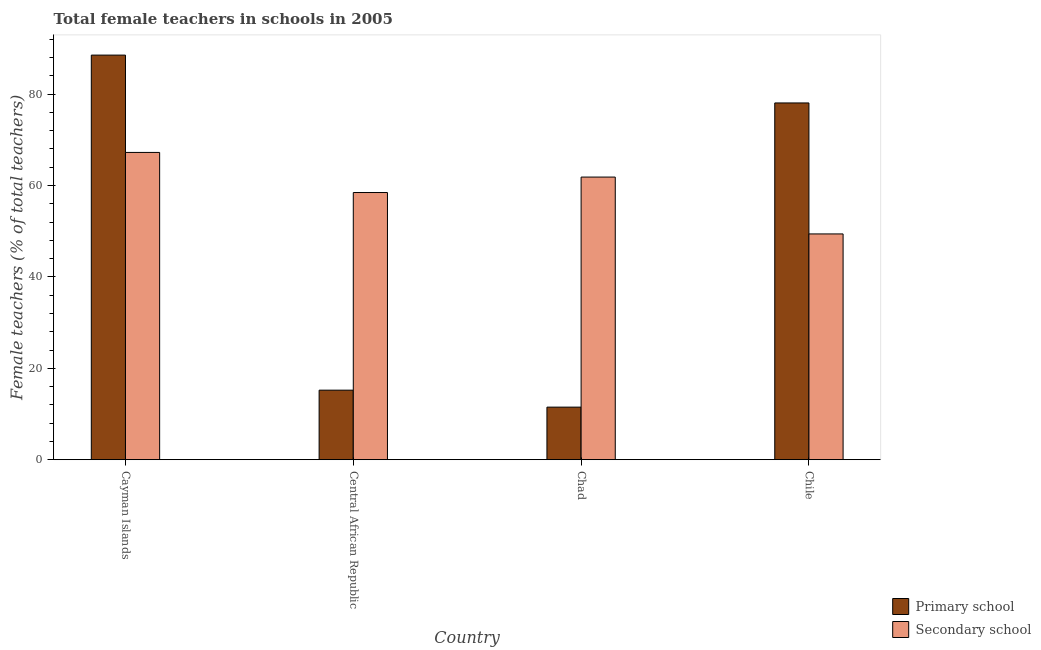How many bars are there on the 2nd tick from the left?
Your answer should be very brief. 2. What is the label of the 3rd group of bars from the left?
Offer a terse response. Chad. What is the percentage of female teachers in primary schools in Chad?
Your answer should be compact. 11.5. Across all countries, what is the maximum percentage of female teachers in secondary schools?
Offer a terse response. 67.24. Across all countries, what is the minimum percentage of female teachers in secondary schools?
Offer a terse response. 49.41. In which country was the percentage of female teachers in primary schools maximum?
Make the answer very short. Cayman Islands. In which country was the percentage of female teachers in primary schools minimum?
Give a very brief answer. Chad. What is the total percentage of female teachers in secondary schools in the graph?
Provide a succinct answer. 236.96. What is the difference between the percentage of female teachers in secondary schools in Chad and that in Chile?
Your answer should be compact. 12.44. What is the difference between the percentage of female teachers in secondary schools in Chad and the percentage of female teachers in primary schools in Central African Republic?
Offer a terse response. 46.63. What is the average percentage of female teachers in primary schools per country?
Provide a short and direct response. 48.33. What is the difference between the percentage of female teachers in primary schools and percentage of female teachers in secondary schools in Chad?
Provide a succinct answer. -50.35. What is the ratio of the percentage of female teachers in primary schools in Cayman Islands to that in Chile?
Provide a short and direct response. 1.13. Is the percentage of female teachers in primary schools in Cayman Islands less than that in Central African Republic?
Your answer should be very brief. No. Is the difference between the percentage of female teachers in secondary schools in Central African Republic and Chad greater than the difference between the percentage of female teachers in primary schools in Central African Republic and Chad?
Provide a succinct answer. No. What is the difference between the highest and the second highest percentage of female teachers in primary schools?
Make the answer very short. 10.47. What is the difference between the highest and the lowest percentage of female teachers in primary schools?
Provide a succinct answer. 77.04. In how many countries, is the percentage of female teachers in primary schools greater than the average percentage of female teachers in primary schools taken over all countries?
Give a very brief answer. 2. Is the sum of the percentage of female teachers in secondary schools in Central African Republic and Chile greater than the maximum percentage of female teachers in primary schools across all countries?
Make the answer very short. Yes. What does the 1st bar from the left in Chad represents?
Keep it short and to the point. Primary school. What does the 2nd bar from the right in Chile represents?
Make the answer very short. Primary school. Are all the bars in the graph horizontal?
Provide a short and direct response. No. Are the values on the major ticks of Y-axis written in scientific E-notation?
Give a very brief answer. No. Does the graph contain any zero values?
Offer a terse response. No. Where does the legend appear in the graph?
Give a very brief answer. Bottom right. How many legend labels are there?
Make the answer very short. 2. How are the legend labels stacked?
Keep it short and to the point. Vertical. What is the title of the graph?
Your answer should be compact. Total female teachers in schools in 2005. What is the label or title of the Y-axis?
Your answer should be compact. Female teachers (% of total teachers). What is the Female teachers (% of total teachers) of Primary school in Cayman Islands?
Make the answer very short. 88.54. What is the Female teachers (% of total teachers) in Secondary school in Cayman Islands?
Offer a terse response. 67.24. What is the Female teachers (% of total teachers) of Primary school in Central African Republic?
Ensure brevity in your answer.  15.22. What is the Female teachers (% of total teachers) in Secondary school in Central African Republic?
Keep it short and to the point. 58.47. What is the Female teachers (% of total teachers) in Primary school in Chad?
Make the answer very short. 11.5. What is the Female teachers (% of total teachers) in Secondary school in Chad?
Provide a short and direct response. 61.85. What is the Female teachers (% of total teachers) in Primary school in Chile?
Make the answer very short. 78.07. What is the Female teachers (% of total teachers) of Secondary school in Chile?
Your answer should be very brief. 49.41. Across all countries, what is the maximum Female teachers (% of total teachers) in Primary school?
Offer a terse response. 88.54. Across all countries, what is the maximum Female teachers (% of total teachers) of Secondary school?
Keep it short and to the point. 67.24. Across all countries, what is the minimum Female teachers (% of total teachers) of Primary school?
Make the answer very short. 11.5. Across all countries, what is the minimum Female teachers (% of total teachers) of Secondary school?
Offer a terse response. 49.41. What is the total Female teachers (% of total teachers) of Primary school in the graph?
Your response must be concise. 193.32. What is the total Female teachers (% of total teachers) of Secondary school in the graph?
Your response must be concise. 236.96. What is the difference between the Female teachers (% of total teachers) of Primary school in Cayman Islands and that in Central African Republic?
Your answer should be very brief. 73.32. What is the difference between the Female teachers (% of total teachers) of Secondary school in Cayman Islands and that in Central African Republic?
Keep it short and to the point. 8.77. What is the difference between the Female teachers (% of total teachers) of Primary school in Cayman Islands and that in Chad?
Offer a terse response. 77.04. What is the difference between the Female teachers (% of total teachers) in Secondary school in Cayman Islands and that in Chad?
Your answer should be very brief. 5.39. What is the difference between the Female teachers (% of total teachers) of Primary school in Cayman Islands and that in Chile?
Your answer should be very brief. 10.47. What is the difference between the Female teachers (% of total teachers) in Secondary school in Cayman Islands and that in Chile?
Give a very brief answer. 17.83. What is the difference between the Female teachers (% of total teachers) in Primary school in Central African Republic and that in Chad?
Keep it short and to the point. 3.71. What is the difference between the Female teachers (% of total teachers) of Secondary school in Central African Republic and that in Chad?
Offer a very short reply. -3.38. What is the difference between the Female teachers (% of total teachers) in Primary school in Central African Republic and that in Chile?
Your answer should be very brief. -62.85. What is the difference between the Female teachers (% of total teachers) in Secondary school in Central African Republic and that in Chile?
Offer a terse response. 9.06. What is the difference between the Female teachers (% of total teachers) of Primary school in Chad and that in Chile?
Provide a succinct answer. -66.57. What is the difference between the Female teachers (% of total teachers) of Secondary school in Chad and that in Chile?
Your response must be concise. 12.44. What is the difference between the Female teachers (% of total teachers) of Primary school in Cayman Islands and the Female teachers (% of total teachers) of Secondary school in Central African Republic?
Your answer should be very brief. 30.07. What is the difference between the Female teachers (% of total teachers) of Primary school in Cayman Islands and the Female teachers (% of total teachers) of Secondary school in Chad?
Ensure brevity in your answer.  26.69. What is the difference between the Female teachers (% of total teachers) of Primary school in Cayman Islands and the Female teachers (% of total teachers) of Secondary school in Chile?
Offer a very short reply. 39.13. What is the difference between the Female teachers (% of total teachers) in Primary school in Central African Republic and the Female teachers (% of total teachers) in Secondary school in Chad?
Your response must be concise. -46.63. What is the difference between the Female teachers (% of total teachers) in Primary school in Central African Republic and the Female teachers (% of total teachers) in Secondary school in Chile?
Provide a succinct answer. -34.19. What is the difference between the Female teachers (% of total teachers) of Primary school in Chad and the Female teachers (% of total teachers) of Secondary school in Chile?
Your answer should be very brief. -37.91. What is the average Female teachers (% of total teachers) in Primary school per country?
Offer a terse response. 48.33. What is the average Female teachers (% of total teachers) of Secondary school per country?
Offer a terse response. 59.24. What is the difference between the Female teachers (% of total teachers) in Primary school and Female teachers (% of total teachers) in Secondary school in Cayman Islands?
Make the answer very short. 21.3. What is the difference between the Female teachers (% of total teachers) of Primary school and Female teachers (% of total teachers) of Secondary school in Central African Republic?
Keep it short and to the point. -43.25. What is the difference between the Female teachers (% of total teachers) of Primary school and Female teachers (% of total teachers) of Secondary school in Chad?
Your response must be concise. -50.35. What is the difference between the Female teachers (% of total teachers) of Primary school and Female teachers (% of total teachers) of Secondary school in Chile?
Give a very brief answer. 28.66. What is the ratio of the Female teachers (% of total teachers) in Primary school in Cayman Islands to that in Central African Republic?
Make the answer very short. 5.82. What is the ratio of the Female teachers (% of total teachers) of Secondary school in Cayman Islands to that in Central African Republic?
Ensure brevity in your answer.  1.15. What is the ratio of the Female teachers (% of total teachers) of Primary school in Cayman Islands to that in Chad?
Ensure brevity in your answer.  7.7. What is the ratio of the Female teachers (% of total teachers) of Secondary school in Cayman Islands to that in Chad?
Make the answer very short. 1.09. What is the ratio of the Female teachers (% of total teachers) in Primary school in Cayman Islands to that in Chile?
Give a very brief answer. 1.13. What is the ratio of the Female teachers (% of total teachers) of Secondary school in Cayman Islands to that in Chile?
Make the answer very short. 1.36. What is the ratio of the Female teachers (% of total teachers) of Primary school in Central African Republic to that in Chad?
Provide a succinct answer. 1.32. What is the ratio of the Female teachers (% of total teachers) of Secondary school in Central African Republic to that in Chad?
Give a very brief answer. 0.95. What is the ratio of the Female teachers (% of total teachers) in Primary school in Central African Republic to that in Chile?
Provide a short and direct response. 0.19. What is the ratio of the Female teachers (% of total teachers) of Secondary school in Central African Republic to that in Chile?
Give a very brief answer. 1.18. What is the ratio of the Female teachers (% of total teachers) of Primary school in Chad to that in Chile?
Ensure brevity in your answer.  0.15. What is the ratio of the Female teachers (% of total teachers) in Secondary school in Chad to that in Chile?
Your answer should be very brief. 1.25. What is the difference between the highest and the second highest Female teachers (% of total teachers) in Primary school?
Offer a terse response. 10.47. What is the difference between the highest and the second highest Female teachers (% of total teachers) of Secondary school?
Provide a short and direct response. 5.39. What is the difference between the highest and the lowest Female teachers (% of total teachers) of Primary school?
Your answer should be very brief. 77.04. What is the difference between the highest and the lowest Female teachers (% of total teachers) in Secondary school?
Your answer should be compact. 17.83. 